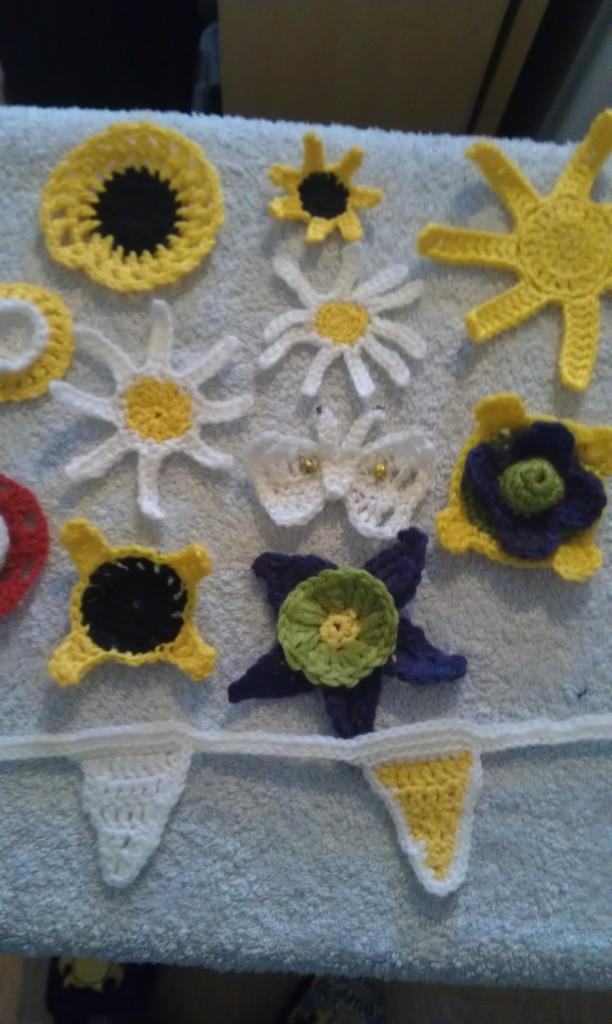What object is in the center of the image? There is a towel in the center of the image. What is on the towel? There are woolen flowers on the towel. What type of stitch is used to create the woolen flowers on the towel? There is no information provided about the type of stitch used to create the woolen flowers on the towel. How does the current affect the towel in the image? There is no reference to a current in the image, so it is not possible to determine how it might affect the towel. 